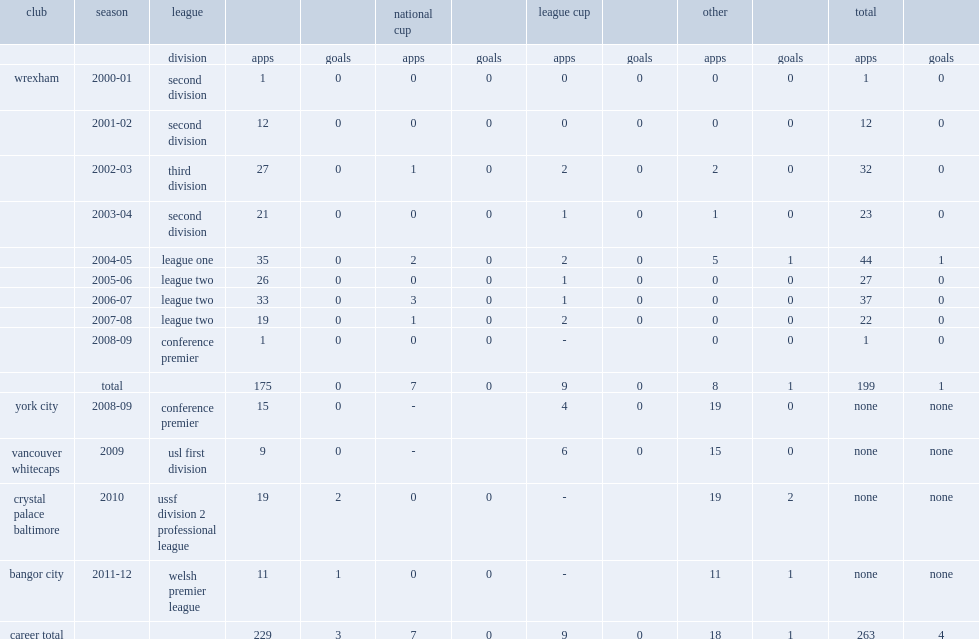In 2010, which league did shaun pejic join club crystal palace baltimore? Ussf division 2 professional league. 